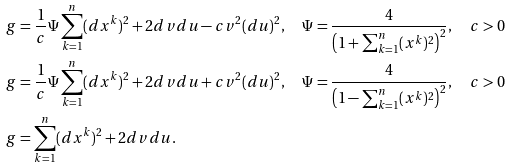<formula> <loc_0><loc_0><loc_500><loc_500>g & = \frac { 1 } { c } \Psi \sum _ { k = 1 } ^ { n } ( d x ^ { k } ) ^ { 2 } + 2 d v d u - c v ^ { 2 } ( d u ) ^ { 2 } , \quad \Psi = \frac { 4 } { \left ( 1 + \sum _ { k = 1 } ^ { n } ( x ^ { k } ) ^ { 2 } \right ) ^ { 2 } } , \quad c > 0 \\ g & = \frac { 1 } { c } \Psi \sum _ { k = 1 } ^ { n } ( d x ^ { k } ) ^ { 2 } + 2 d v d u + c v ^ { 2 } ( d u ) ^ { 2 } , \quad \Psi = \frac { 4 } { \left ( 1 - \sum _ { k = 1 } ^ { n } ( x ^ { k } ) ^ { 2 } \right ) ^ { 2 } } , \quad c > 0 \\ g & = \sum _ { k = 1 } ^ { n } ( d x ^ { k } ) ^ { 2 } + 2 d v d u .</formula> 